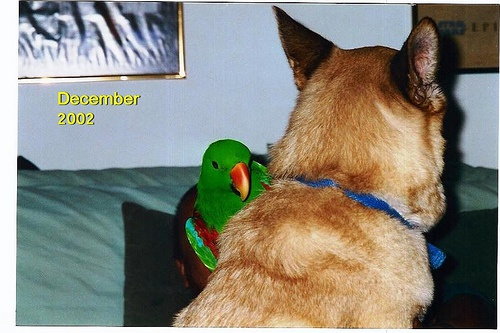Describe the objects in this image and their specific colors. I can see dog in white, brown, and tan tones, bed in white, black, and teal tones, and bird in white, darkgreen, green, black, and maroon tones in this image. 